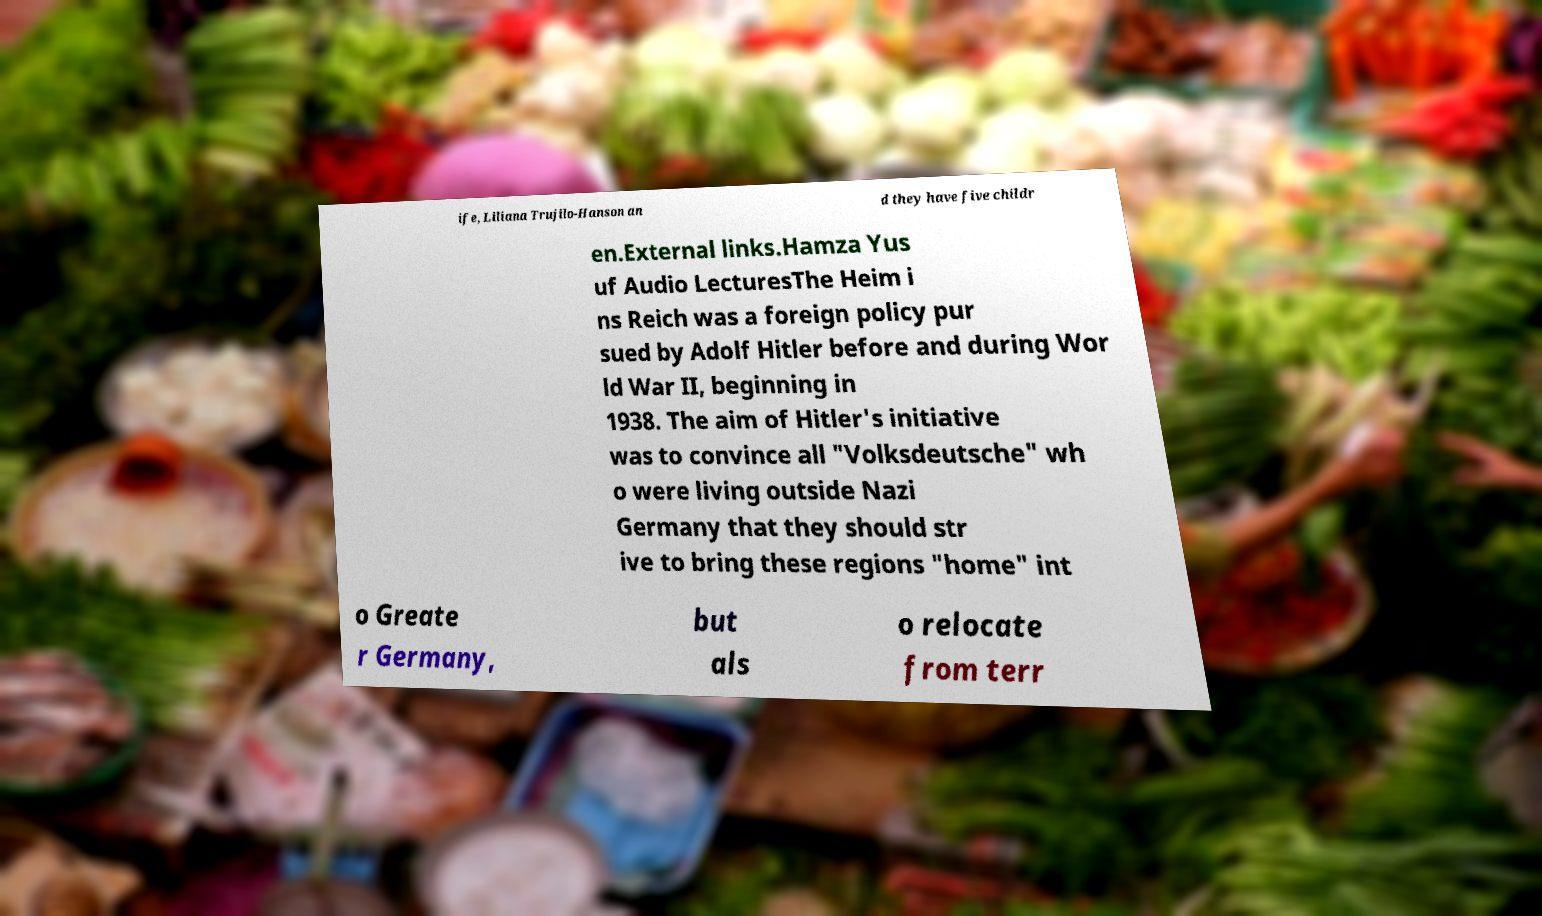There's text embedded in this image that I need extracted. Can you transcribe it verbatim? ife, Liliana Trujilo-Hanson an d they have five childr en.External links.Hamza Yus uf Audio LecturesThe Heim i ns Reich was a foreign policy pur sued by Adolf Hitler before and during Wor ld War II, beginning in 1938. The aim of Hitler's initiative was to convince all "Volksdeutsche" wh o were living outside Nazi Germany that they should str ive to bring these regions "home" int o Greate r Germany, but als o relocate from terr 